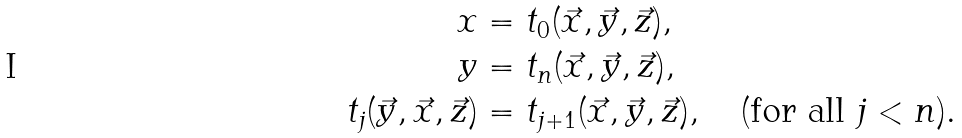<formula> <loc_0><loc_0><loc_500><loc_500>x & = t _ { 0 } ( \vec { x } , \vec { y } , \vec { z } ) , \\ y & = t _ { n } ( \vec { x } , \vec { y } , \vec { z } ) , \\ t _ { j } ( \vec { y } , \vec { x } , \vec { z } ) & = t _ { j + 1 } ( \vec { x } , \vec { y } , \vec { z } ) , \quad ( \text {for all } j < n ) .</formula> 